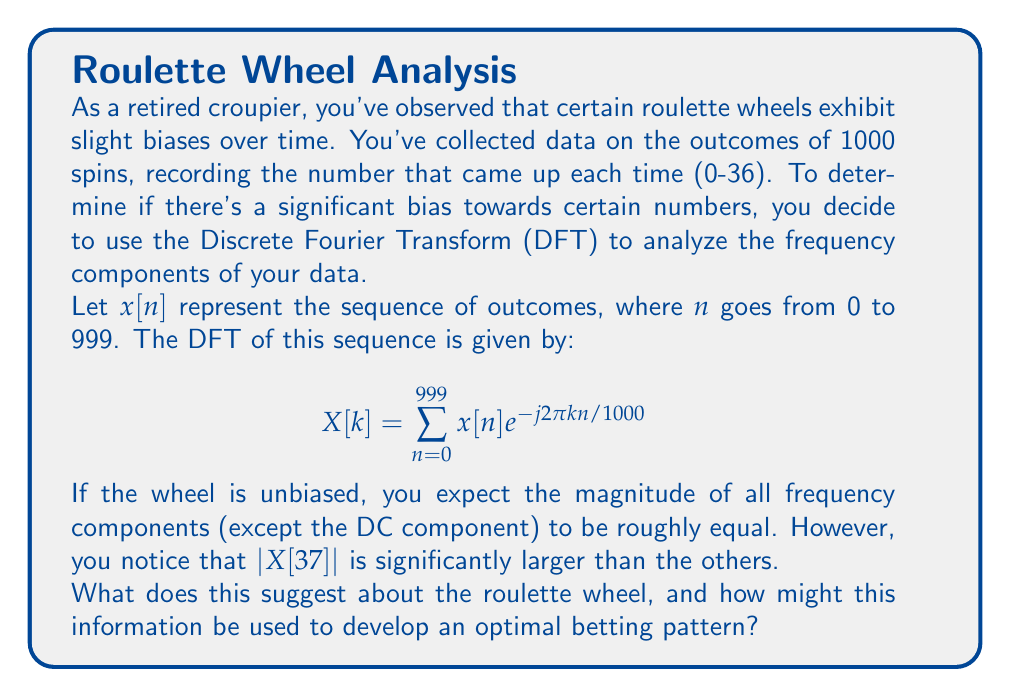Show me your answer to this math problem. Let's break this down step-by-step:

1) The Discrete Fourier Transform (DFT) is used to convert a sequence from the time domain to the frequency domain. In this case, we're using it to analyze the frequency of occurrence of different numbers on the roulette wheel.

2) The formula given is the standard DFT equation, where:
   - $x[n]$ is the input sequence (the roulette outcomes)
   - $X[k]$ is the kth frequency component
   - $N = 1000$ is the number of samples

3) For an unbiased roulette wheel, we would expect each number to appear with equal probability. In the frequency domain, this would result in a relatively flat spectrum (except for the DC component $X[0]$, which represents the average).

4) The fact that $|X[37]|$ is significantly larger than other components is crucial. Here's why:
   - There are 37 numbers on a standard European roulette wheel (0-36).
   - $X[37]$ corresponds to a frequency of $37/1000 = 0.037$ cycles per spin.
   - This means there's a strong periodic component that repeats every $1/0.037 \approx 27$ spins.

5) This suggests that the roulette wheel has a bias that causes certain numbers or sections to appear more frequently in a pattern that repeats approximately every 27 spins.

6) To develop an optimal betting pattern based on this information:
   - Observe the wheel for 27 spins to identify which numbers or sections are favored.
   - Place bets on these favored numbers or sections for the next 27 spins.
   - Repeat this cycle, adjusting for any changes in the pattern.

7) It's important to note that exploiting such a bias would be considered cheating and is illegal in most jurisdictions. As a retired croupier, you should advise against using this information for personal gain and instead report the biased wheel to the casino management.
Answer: The large $|X[37]|$ indicates a periodic bias repeating every ~27 spins, suggesting certain numbers appear more frequently. This could be exploited for betting, but doing so would be unethical and illegal. 